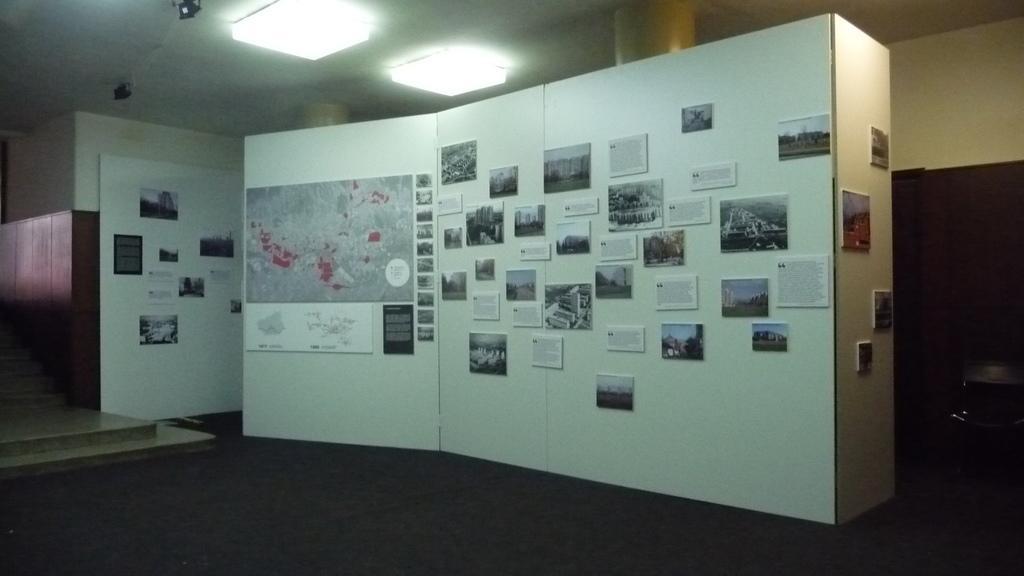In one or two sentences, can you explain what this image depicts? On this white wall we can see map, pictures and posters. Lights are attached to the ceiling. Here we can see a chair.  